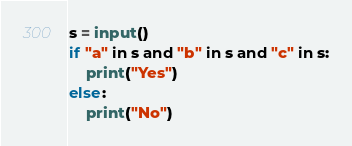Convert code to text. <code><loc_0><loc_0><loc_500><loc_500><_Python_>s = input()
if "a" in s and "b" in s and "c" in s:
    print("Yes")
else:
    print("No")</code> 